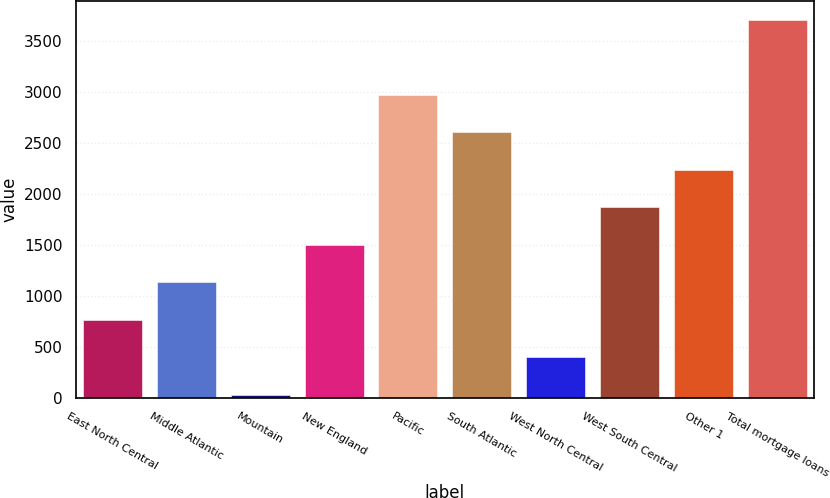<chart> <loc_0><loc_0><loc_500><loc_500><bar_chart><fcel>East North Central<fcel>Middle Atlantic<fcel>Mountain<fcel>New England<fcel>Pacific<fcel>South Atlantic<fcel>West North Central<fcel>West South Central<fcel>Other 1<fcel>Total mortgage loans<nl><fcel>764.8<fcel>1132.2<fcel>30<fcel>1499.6<fcel>2969.2<fcel>2601.8<fcel>397.4<fcel>1867<fcel>2234.4<fcel>3704<nl></chart> 